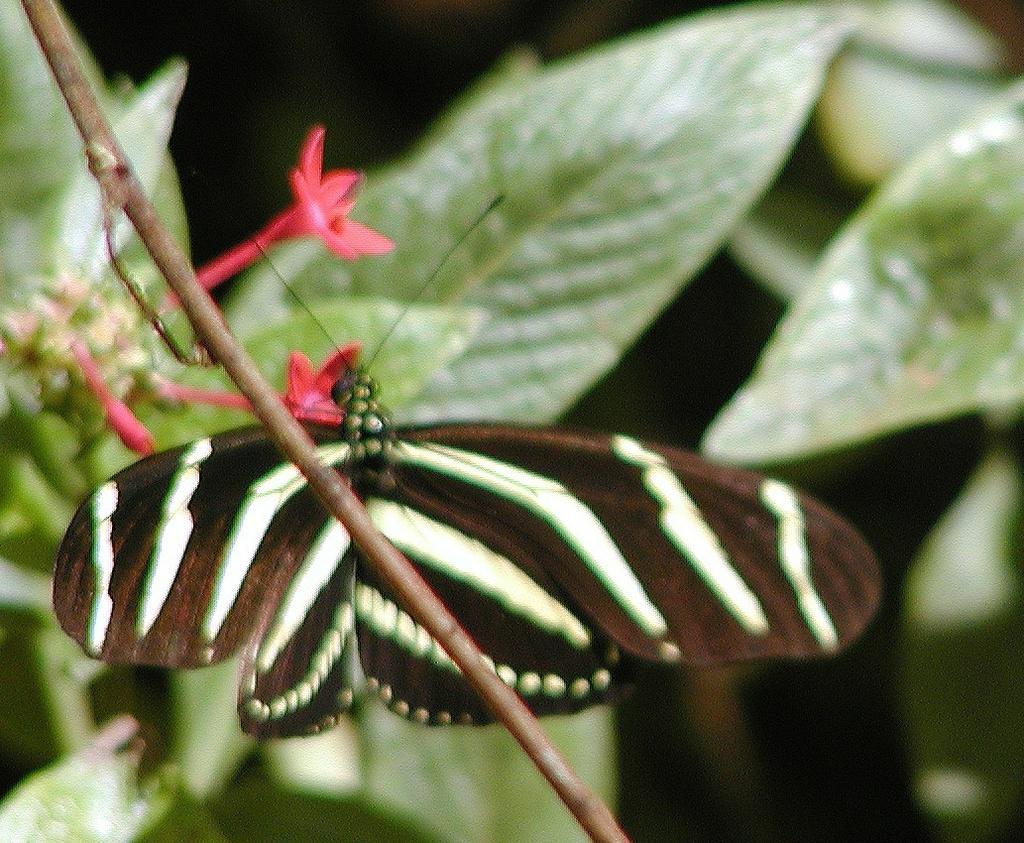Could you give a brief overview of what you see in this image? In this picture we can see one butterfly is flying on the plant. 